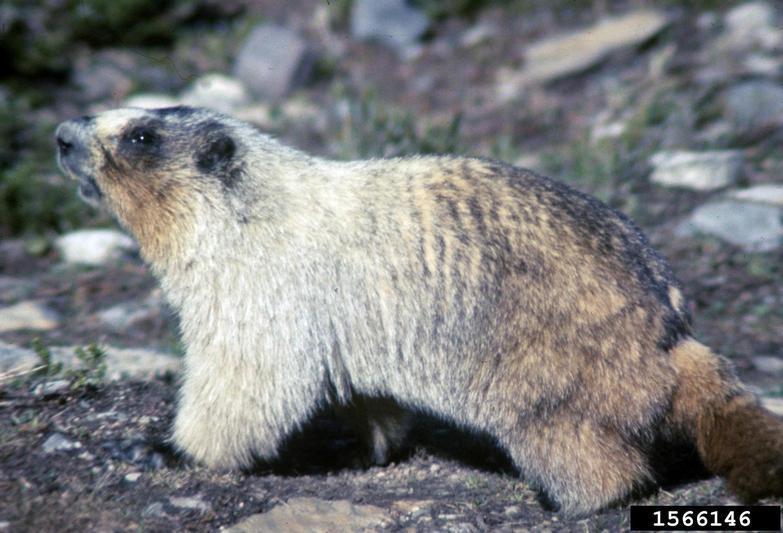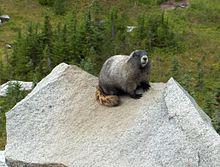The first image is the image on the left, the second image is the image on the right. Considering the images on both sides, is "The animal is facing left in the left image and right in the right image." valid? Answer yes or no. Yes. 